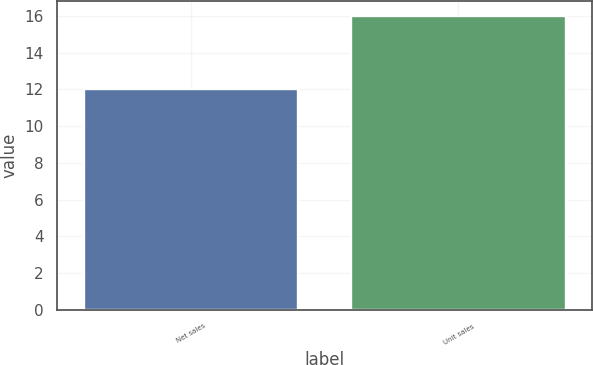Convert chart to OTSL. <chart><loc_0><loc_0><loc_500><loc_500><bar_chart><fcel>Net sales<fcel>Unit sales<nl><fcel>12<fcel>16<nl></chart> 